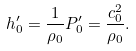Convert formula to latex. <formula><loc_0><loc_0><loc_500><loc_500>h _ { 0 } ^ { \prime } = \frac { 1 } { \rho _ { 0 } } P _ { 0 } ^ { \prime } = \frac { c _ { 0 } ^ { 2 } } { \rho _ { 0 } } .</formula> 